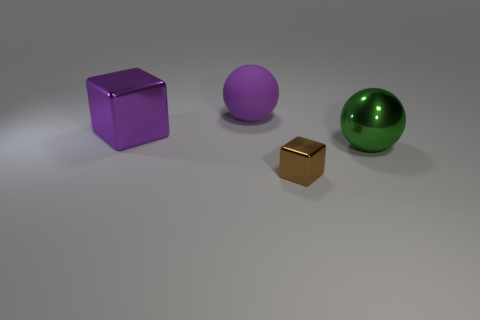Add 1 purple metallic objects. How many objects exist? 5 Subtract all green objects. Subtract all small metal things. How many objects are left? 2 Add 1 big green shiny balls. How many big green shiny balls are left? 2 Add 4 cubes. How many cubes exist? 6 Subtract 0 yellow spheres. How many objects are left? 4 